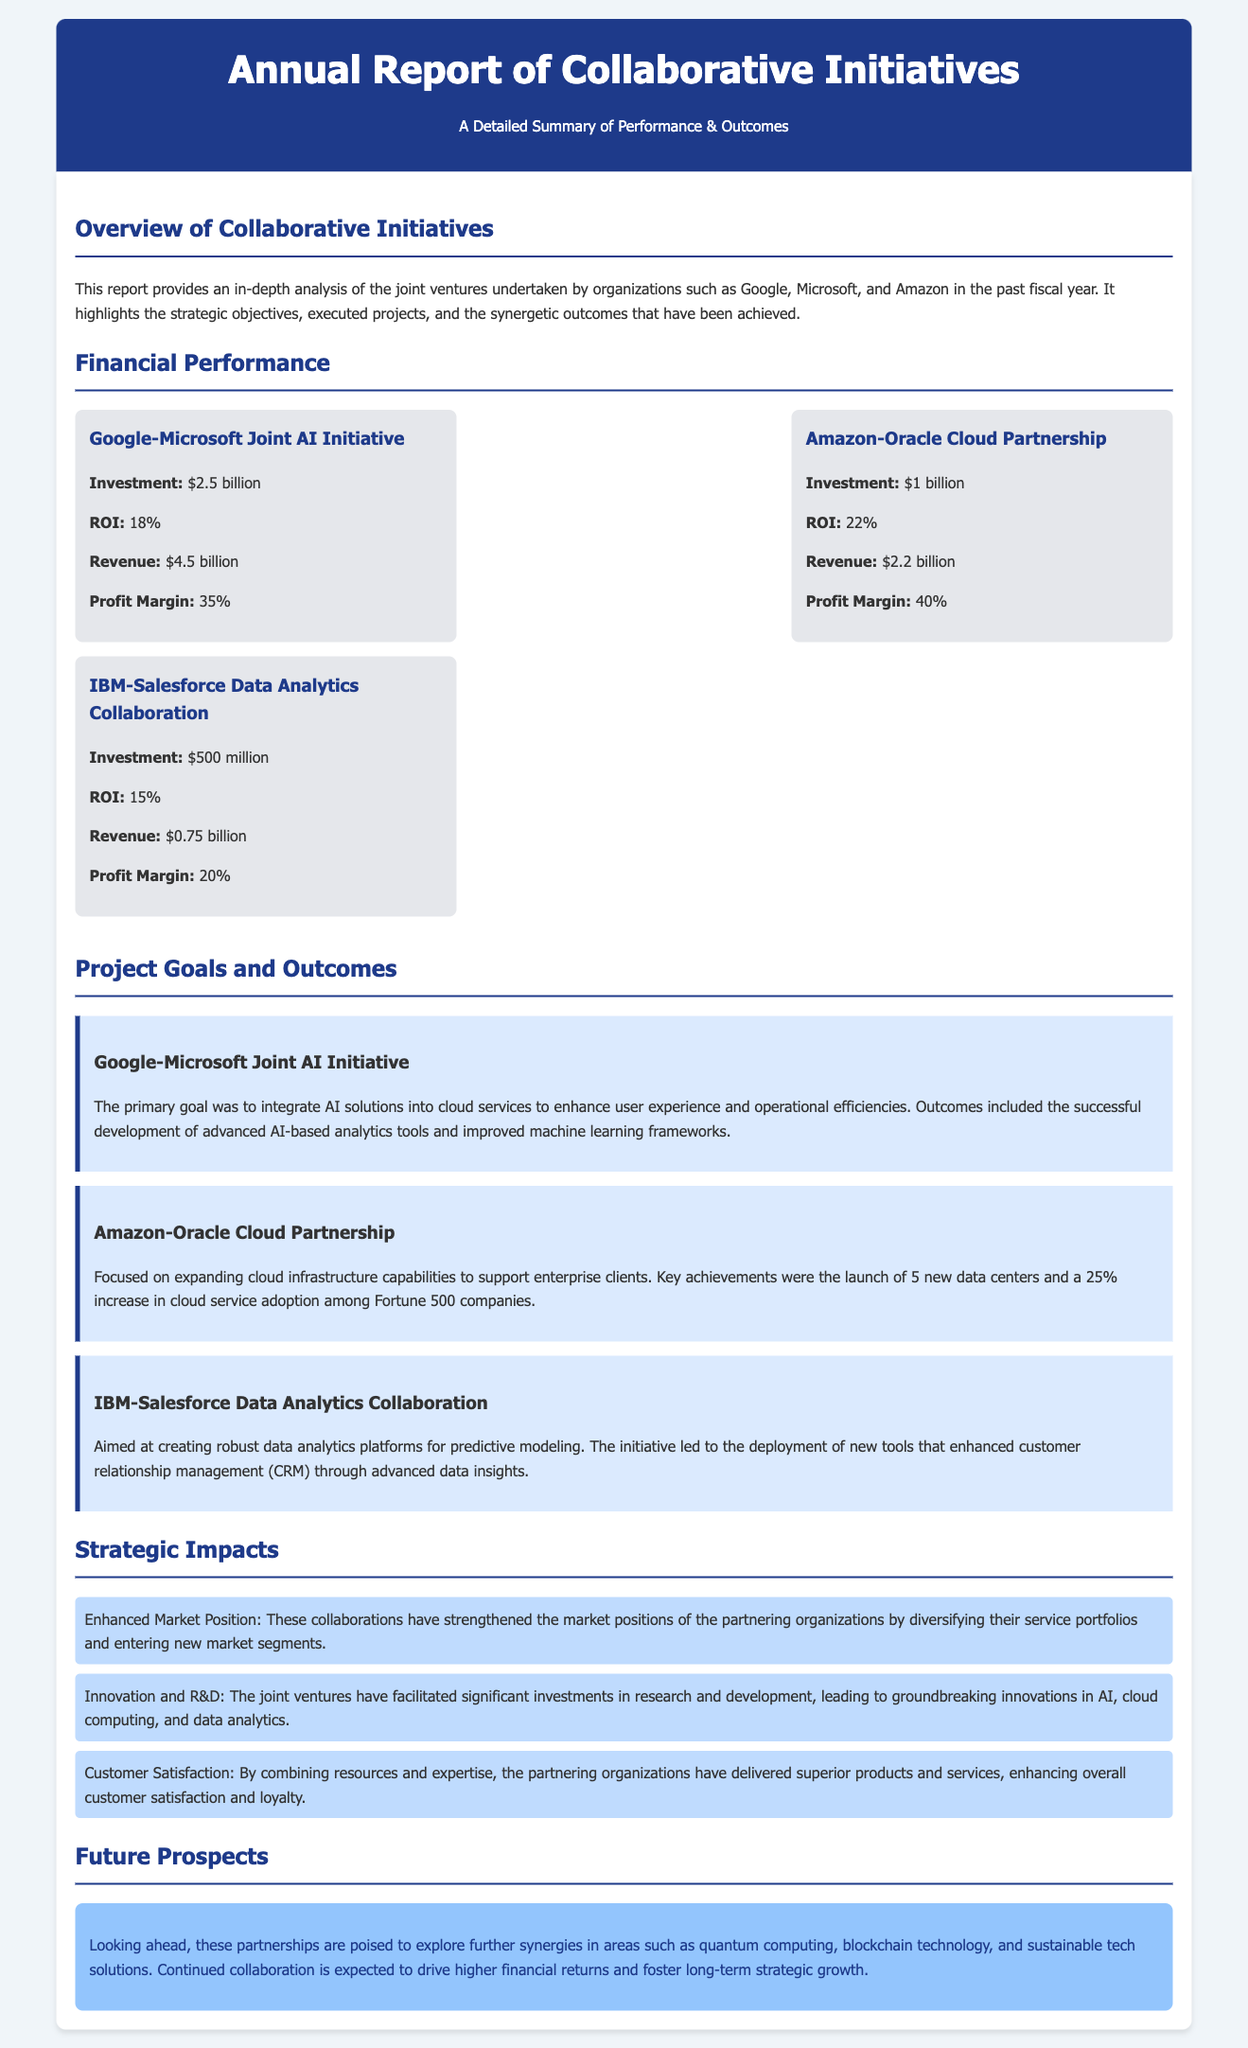what was the investment in the Google-Microsoft Joint AI Initiative? The document states that the investment was $2.5 billion.
Answer: $2.5 billion what is the ROI for the Amazon-Oracle Cloud Partnership? The document indicates that the ROI for the partnership is 22%.
Answer: 22% how many data centers were launched as part of the Amazon-Oracle Cloud Partnership? The initiative resulted in the launch of 5 new data centers.
Answer: 5 what is one of the future areas of exploration mentioned in the report? The report highlights quantum computing as a future prospect for exploration.
Answer: quantum computing what was a primary goal of the IBM-Salesforce Data Analytics Collaboration? The document mentions the aim of creating robust data analytics platforms for predictive modeling.
Answer: creating robust data analytics platforms how did the collaborations impact customer satisfaction? The document states that the partnerships delivered superior products and services, enhancing customer satisfaction.
Answer: enhancing customer satisfaction which organizations were involved in the joint AI initiative? The involved organizations were Google and Microsoft.
Answer: Google and Microsoft what financial metric indicates the profitability of the IBM-Salesforce collaboration? The profit margin of 20% indicates the profitability of this collaboration.
Answer: 20% 